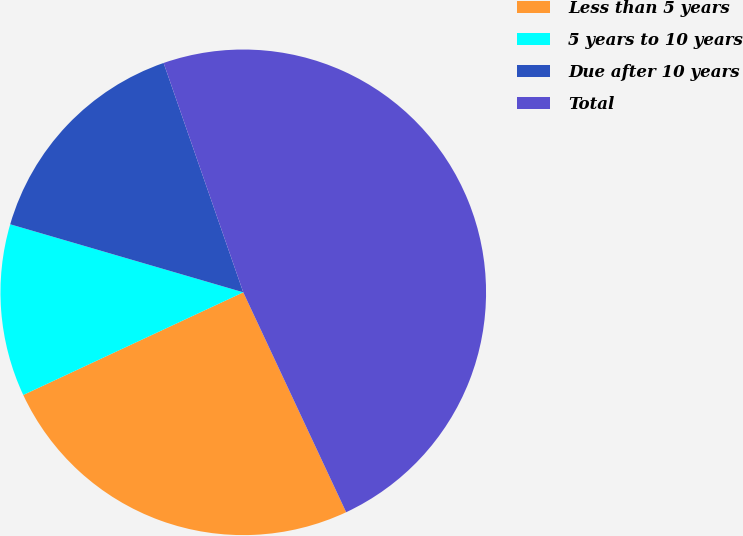Convert chart to OTSL. <chart><loc_0><loc_0><loc_500><loc_500><pie_chart><fcel>Less than 5 years<fcel>5 years to 10 years<fcel>Due after 10 years<fcel>Total<nl><fcel>25.02%<fcel>11.47%<fcel>15.16%<fcel>48.36%<nl></chart> 